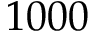Convert formula to latex. <formula><loc_0><loc_0><loc_500><loc_500>1 0 0 0</formula> 